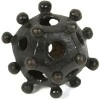Can you guess the material this object is made of? The object appears to have a matte finish and a solid structure, which could suggest it’s made of a type of plastic or resin, materials commonly used in educational models. 